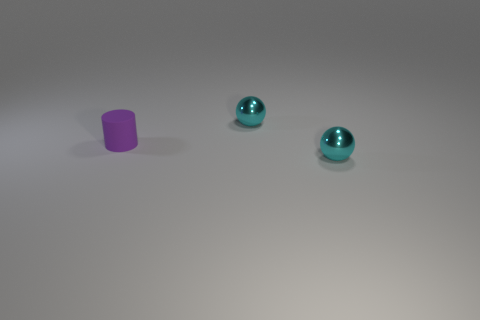Subtract all yellow cylinders. Subtract all green blocks. How many cylinders are left? 1 Add 3 big cyan shiny cubes. How many objects exist? 6 Subtract all cylinders. How many objects are left? 2 Add 1 tiny purple metallic cubes. How many tiny purple metallic cubes exist? 1 Subtract 0 brown spheres. How many objects are left? 3 Subtract all purple matte balls. Subtract all tiny rubber cylinders. How many objects are left? 2 Add 3 tiny purple matte things. How many tiny purple matte things are left? 4 